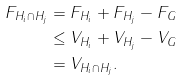Convert formula to latex. <formula><loc_0><loc_0><loc_500><loc_500>F _ { H _ { i } \cap H _ { j } } & = F _ { H _ { i } } + F _ { H _ { j } } - F _ { G } \\ & \leq V _ { H _ { i } } + V _ { H _ { j } } - V _ { G } \\ & = V _ { H _ { i } \cap H _ { j } } .</formula> 